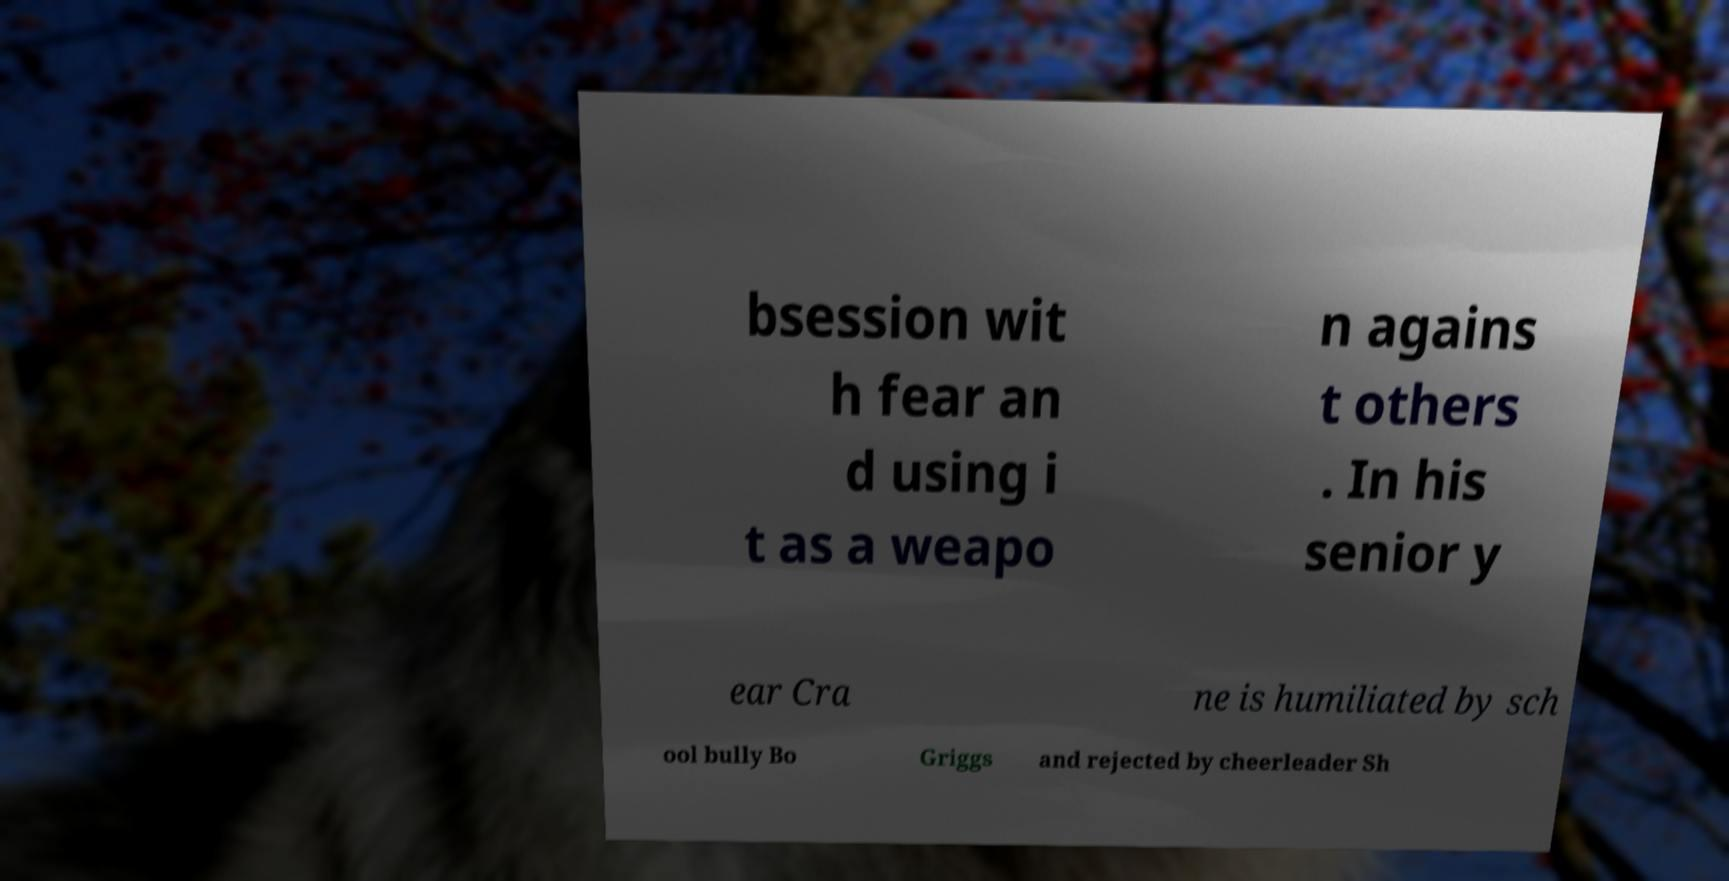Can you accurately transcribe the text from the provided image for me? bsession wit h fear an d using i t as a weapo n agains t others . In his senior y ear Cra ne is humiliated by sch ool bully Bo Griggs and rejected by cheerleader Sh 